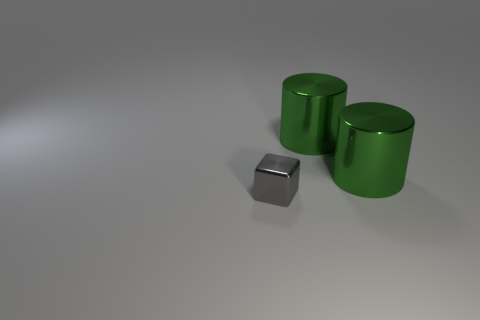Subtract all cylinders. How many objects are left? 1 Subtract all blue cylinders. How many cyan cubes are left? 0 Subtract all gray metal blocks. Subtract all tiny things. How many objects are left? 1 Add 2 gray objects. How many gray objects are left? 3 Add 1 green cylinders. How many green cylinders exist? 3 Add 2 large matte cylinders. How many objects exist? 5 Subtract 0 green cubes. How many objects are left? 3 Subtract all red cubes. Subtract all yellow spheres. How many cubes are left? 1 